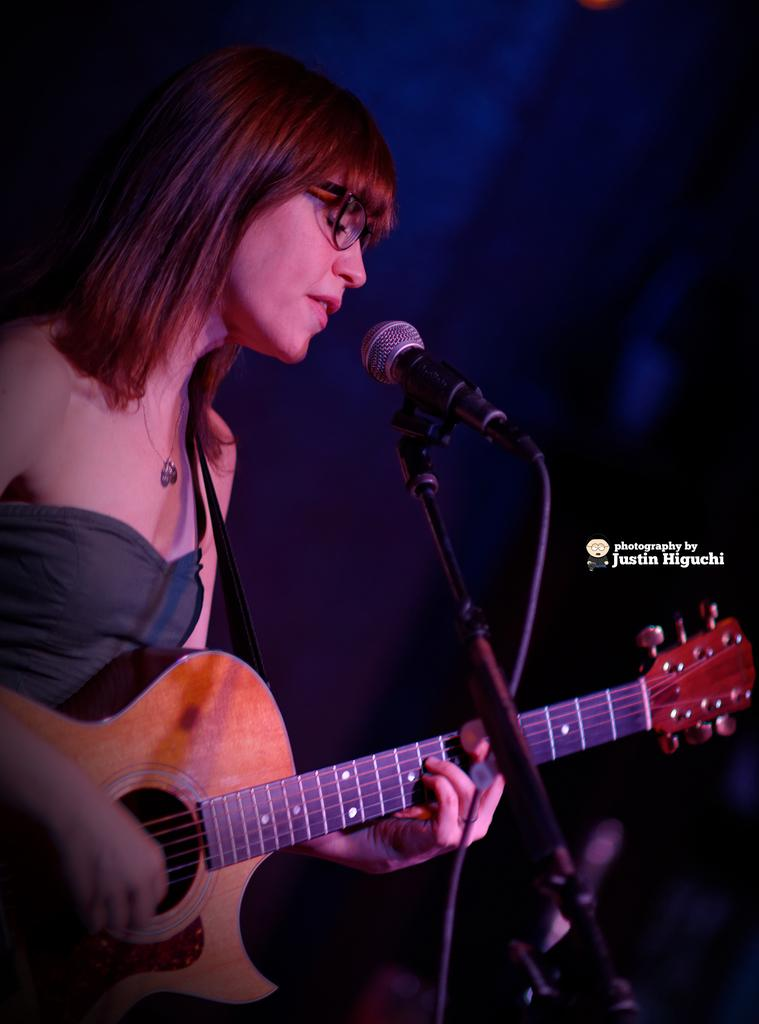Who is the main subject in the image? There is a woman in the image. What is the woman holding in the image? The woman is holding a guitar. What object is in front of the woman? There is a microphone in front of the woman. What color is the dress the woman is wearing? The woman is wearing a black dress. What can be observed about the background of the image? The background of the image is dark. What type of agreement is the woman signing in the image? There is no agreement visible in the image; the woman is holding a guitar and standing in front of a microphone. What kind of root is growing near the woman in the image? There are no roots present in the image; the background is dark. 